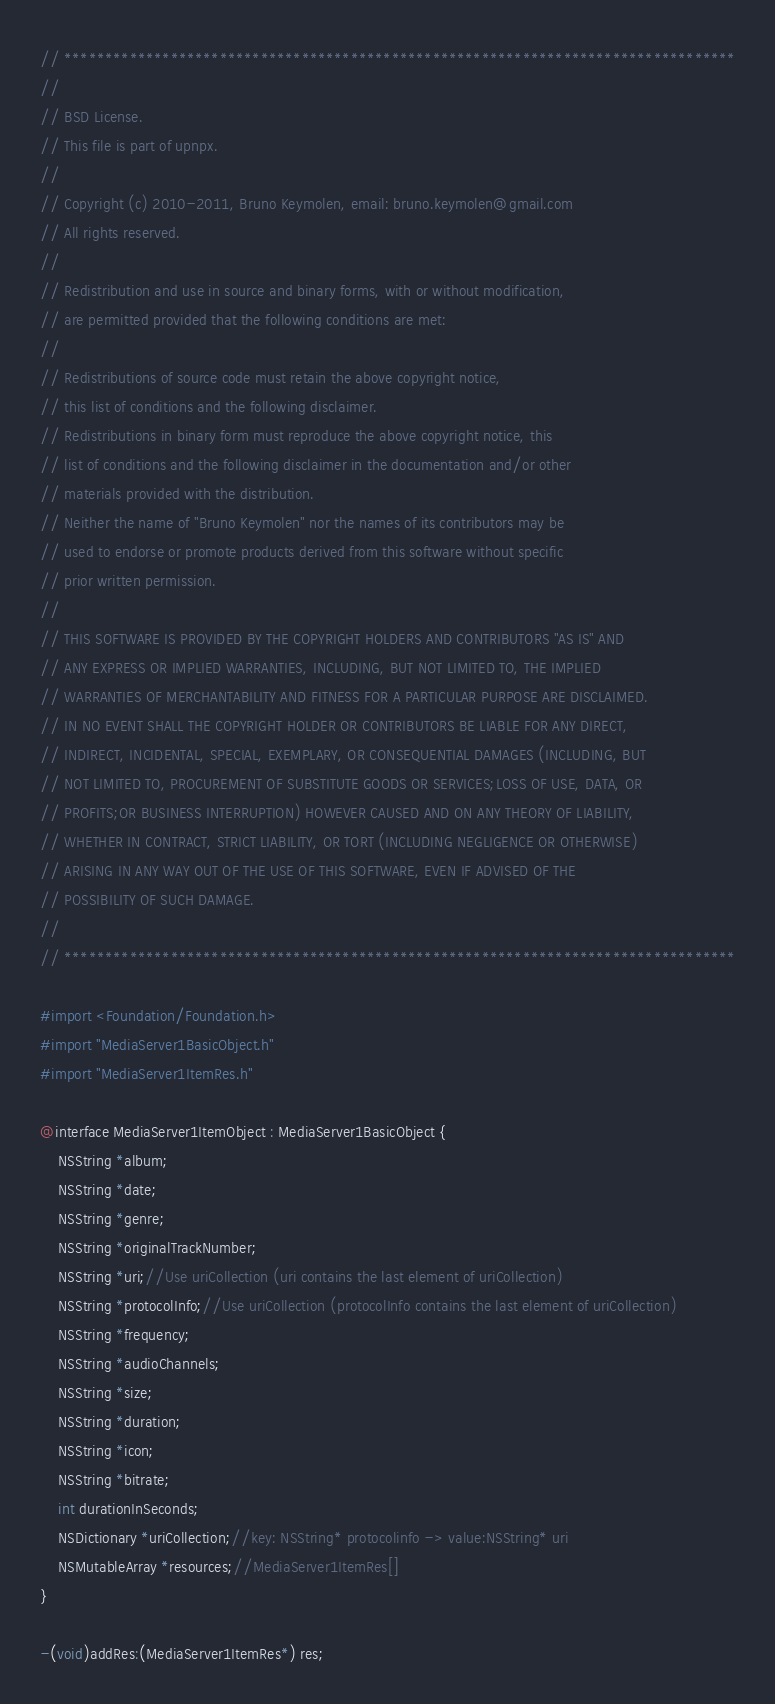<code> <loc_0><loc_0><loc_500><loc_500><_C_>// **********************************************************************************
//
// BSD License.
// This file is part of upnpx.
//
// Copyright (c) 2010-2011, Bruno Keymolen, email: bruno.keymolen@gmail.com
// All rights reserved.
//
// Redistribution and use in source and binary forms, with or without modification, 
// are permitted provided that the following conditions are met:
//
// Redistributions of source code must retain the above copyright notice, 
// this list of conditions and the following disclaimer.
// Redistributions in binary form must reproduce the above copyright notice, this 
// list of conditions and the following disclaimer in the documentation and/or other 
// materials provided with the distribution.
// Neither the name of "Bruno Keymolen" nor the names of its contributors may be 
// used to endorse or promote products derived from this software without specific 
// prior written permission.
//
// THIS SOFTWARE IS PROVIDED BY THE COPYRIGHT HOLDERS AND CONTRIBUTORS "AS IS" AND 
// ANY EXPRESS OR IMPLIED WARRANTIES, INCLUDING, BUT NOT LIMITED TO, THE IMPLIED 
// WARRANTIES OF MERCHANTABILITY AND FITNESS FOR A PARTICULAR PURPOSE ARE DISCLAIMED. 
// IN NO EVENT SHALL THE COPYRIGHT HOLDER OR CONTRIBUTORS BE LIABLE FOR ANY DIRECT, 
// INDIRECT, INCIDENTAL, SPECIAL, EXEMPLARY, OR CONSEQUENTIAL DAMAGES (INCLUDING, BUT 
// NOT LIMITED TO, PROCUREMENT OF SUBSTITUTE GOODS OR SERVICES;LOSS OF USE, DATA, OR 
// PROFITS;OR BUSINESS INTERRUPTION) HOWEVER CAUSED AND ON ANY THEORY OF LIABILITY, 
// WHETHER IN CONTRACT, STRICT LIABILITY, OR TORT (INCLUDING NEGLIGENCE OR OTHERWISE) 
// ARISING IN ANY WAY OUT OF THE USE OF THIS SOFTWARE, EVEN IF ADVISED OF THE 
// POSSIBILITY OF SUCH DAMAGE.
//
// **********************************************************************************

#import <Foundation/Foundation.h>
#import "MediaServer1BasicObject.h"
#import "MediaServer1ItemRes.h"

@interface MediaServer1ItemObject : MediaServer1BasicObject {
    NSString *album;
    NSString *date;
    NSString *genre;
    NSString *originalTrackNumber;
    NSString *uri;//Use uriCollection (uri contains the last element of uriCollection)
    NSString *protocolInfo;//Use uriCollection (protocolInfo contains the last element of uriCollection)
    NSString *frequency;
    NSString *audioChannels;
    NSString *size;
    NSString *duration;
    NSString *icon;
    NSString *bitrate;
    int durationInSeconds;
    NSDictionary *uriCollection;//key: NSString* protocolinfo -> value:NSString* uri
    NSMutableArray *resources;//MediaServer1ItemRes[]
}

-(void)addRes:(MediaServer1ItemRes*) res;
</code> 